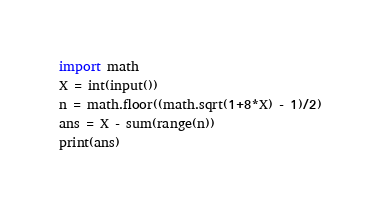<code> <loc_0><loc_0><loc_500><loc_500><_Python_>import math
X = int(input())
n = math.floor((math.sqrt(1+8*X) - 1)/2)
ans = X - sum(range(n))
print(ans)</code> 